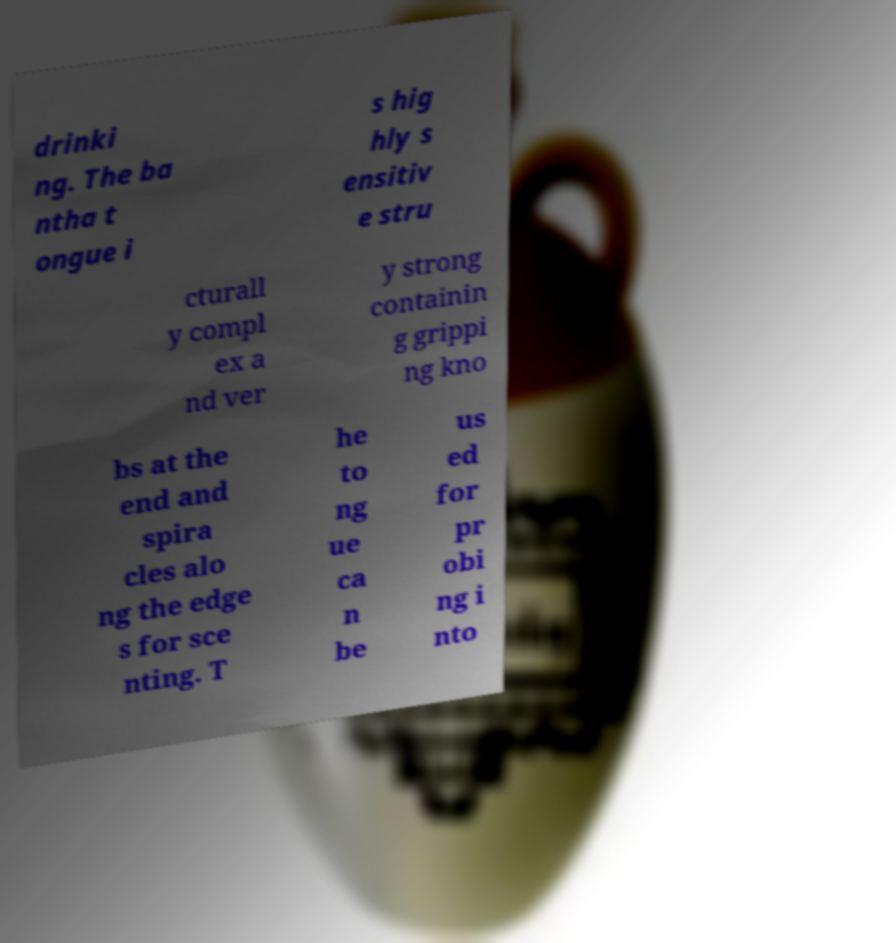I need the written content from this picture converted into text. Can you do that? drinki ng. The ba ntha t ongue i s hig hly s ensitiv e stru cturall y compl ex a nd ver y strong containin g grippi ng kno bs at the end and spira cles alo ng the edge s for sce nting. T he to ng ue ca n be us ed for pr obi ng i nto 